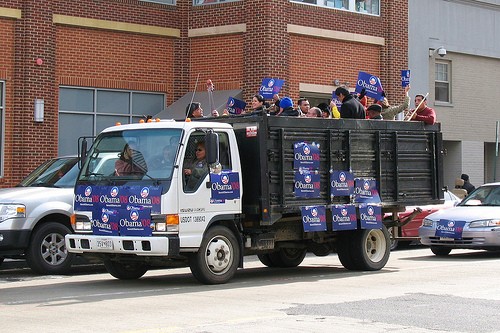Please provide a short description for this region: [0.15, 0.43, 0.18, 0.51]. A black rearview mirror is attached to the truck. 